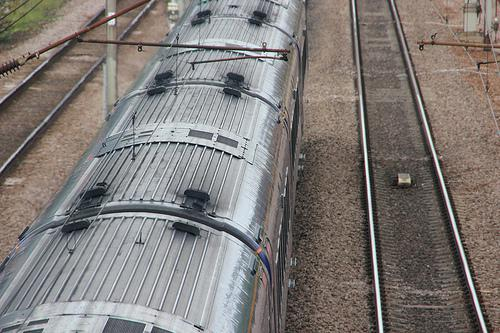Question: who is in the photo?
Choices:
A. A man and a dog.
B. Two boys.
C. Nobody.
D. A bunch of surfers.
Answer with the letter. Answer: C Question: what is on the tracks?
Choices:
A. A locomotive.
B. A commuter train.
C. A trolley.
D. The train.
Answer with the letter. Answer: D Question: what color is the train?
Choices:
A. Silver.
B. Black.
C. Red.
D. Tan.
Answer with the letter. Answer: A Question: what is between the tracks?
Choices:
A. Gravel.
B. Pebbles.
C. Small rocks.
D. Weeds.
Answer with the letter. Answer: B 